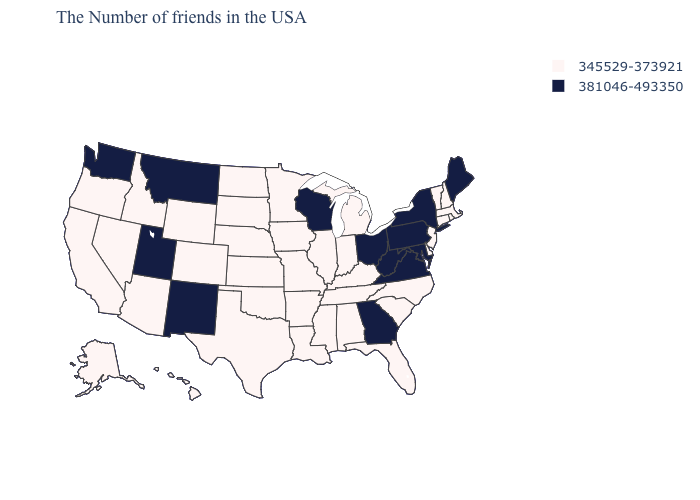Name the states that have a value in the range 345529-373921?
Answer briefly. Massachusetts, Rhode Island, New Hampshire, Vermont, Connecticut, New Jersey, Delaware, North Carolina, South Carolina, Florida, Michigan, Kentucky, Indiana, Alabama, Tennessee, Illinois, Mississippi, Louisiana, Missouri, Arkansas, Minnesota, Iowa, Kansas, Nebraska, Oklahoma, Texas, South Dakota, North Dakota, Wyoming, Colorado, Arizona, Idaho, Nevada, California, Oregon, Alaska, Hawaii. What is the value of Texas?
Answer briefly. 345529-373921. What is the value of Illinois?
Keep it brief. 345529-373921. Among the states that border New Hampshire , which have the highest value?
Give a very brief answer. Maine. What is the lowest value in the South?
Give a very brief answer. 345529-373921. Name the states that have a value in the range 381046-493350?
Give a very brief answer. Maine, New York, Maryland, Pennsylvania, Virginia, West Virginia, Ohio, Georgia, Wisconsin, New Mexico, Utah, Montana, Washington. Which states have the lowest value in the MidWest?
Be succinct. Michigan, Indiana, Illinois, Missouri, Minnesota, Iowa, Kansas, Nebraska, South Dakota, North Dakota. Name the states that have a value in the range 381046-493350?
Quick response, please. Maine, New York, Maryland, Pennsylvania, Virginia, West Virginia, Ohio, Georgia, Wisconsin, New Mexico, Utah, Montana, Washington. Does the first symbol in the legend represent the smallest category?
Concise answer only. Yes. What is the highest value in the USA?
Be succinct. 381046-493350. What is the value of North Carolina?
Give a very brief answer. 345529-373921. Does the map have missing data?
Be succinct. No. Which states have the lowest value in the USA?
Give a very brief answer. Massachusetts, Rhode Island, New Hampshire, Vermont, Connecticut, New Jersey, Delaware, North Carolina, South Carolina, Florida, Michigan, Kentucky, Indiana, Alabama, Tennessee, Illinois, Mississippi, Louisiana, Missouri, Arkansas, Minnesota, Iowa, Kansas, Nebraska, Oklahoma, Texas, South Dakota, North Dakota, Wyoming, Colorado, Arizona, Idaho, Nevada, California, Oregon, Alaska, Hawaii. Which states hav the highest value in the West?
Answer briefly. New Mexico, Utah, Montana, Washington. Name the states that have a value in the range 381046-493350?
Be succinct. Maine, New York, Maryland, Pennsylvania, Virginia, West Virginia, Ohio, Georgia, Wisconsin, New Mexico, Utah, Montana, Washington. 